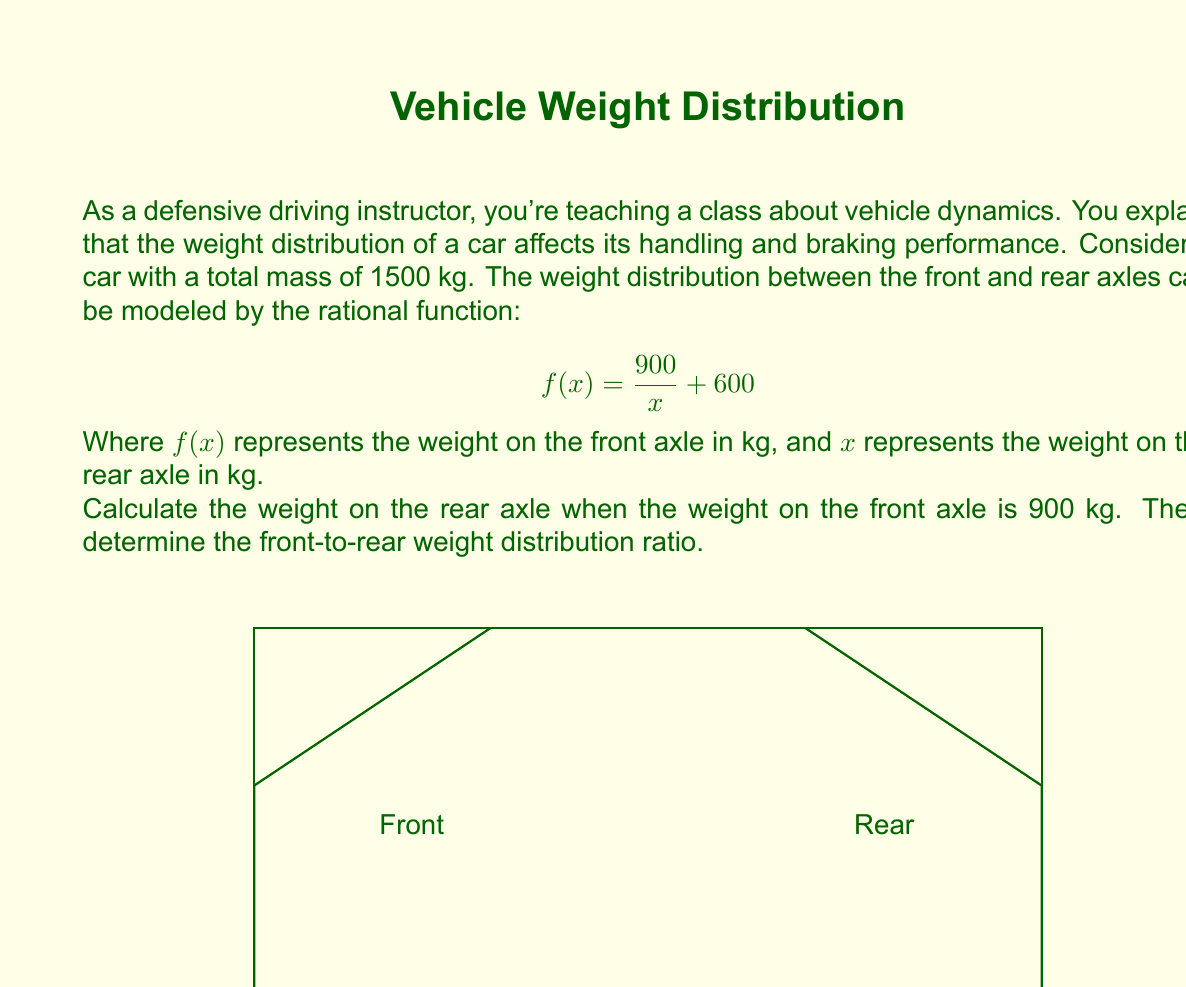Could you help me with this problem? Let's approach this step-by-step:

1) We're given that the weight on the front axle is 900 kg. We need to find $x$ (the weight on the rear axle) when $f(x) = 900$.

2) Substitute these values into the equation:

   $$900 = \frac{900}{x} + 600$$

3) Subtract 600 from both sides:

   $$300 = \frac{900}{x}$$

4) Multiply both sides by $x$:

   $$300x = 900$$

5) Divide both sides by 300:

   $$x = 3$$

6) Therefore, when the front axle weight is 900 kg, the rear axle weight is 600 kg.

7) To calculate the front-to-rear weight distribution ratio:
   Front : Rear = 900 : 600 = 3 : 2

8) To express this as a percentage:
   Front: $\frac{900}{1500} \times 100\% = 60\%$
   Rear: $\frac{600}{1500} \times 100\% = 40\%$

So the weight distribution is 60% front, 40% rear.
Answer: 600 kg; 60:40 